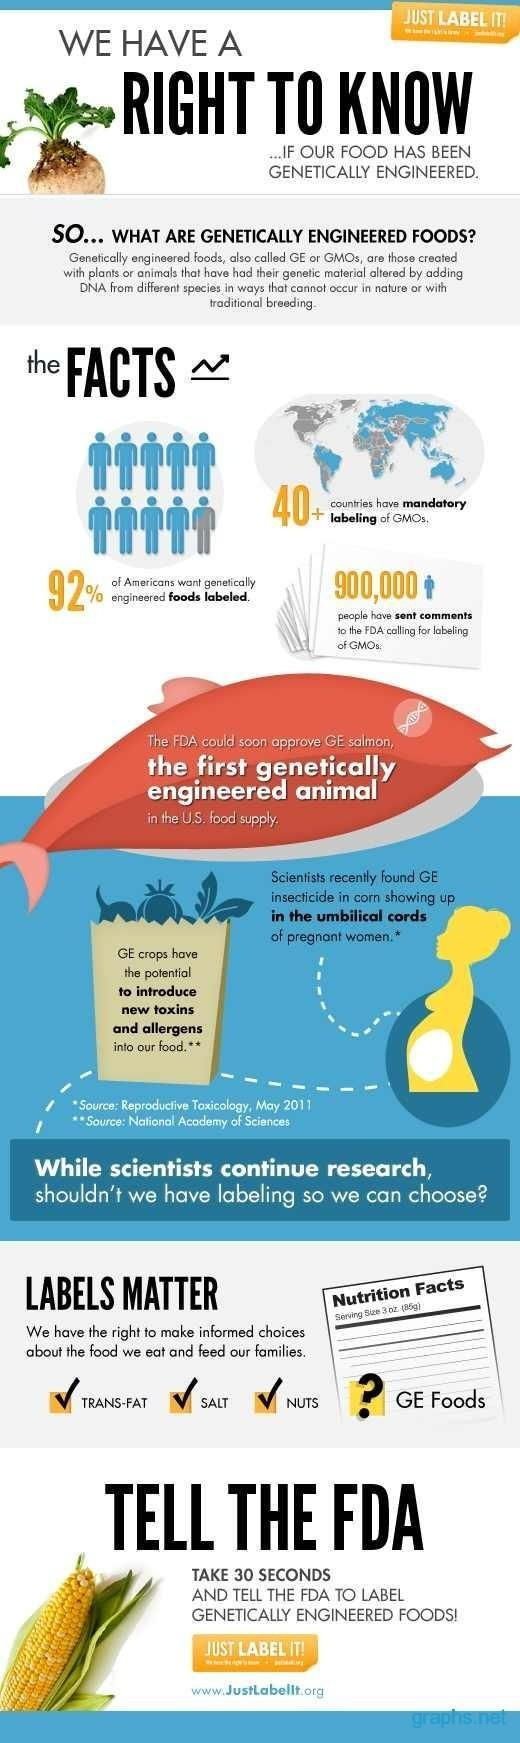What is the inverse percentage of Americans who support food labeling?
Answer the question with a short phrase. 8 